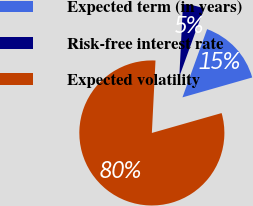<chart> <loc_0><loc_0><loc_500><loc_500><pie_chart><fcel>Expected term (in years)<fcel>Risk-free interest rate<fcel>Expected volatility<nl><fcel>15.06%<fcel>4.72%<fcel>80.22%<nl></chart> 